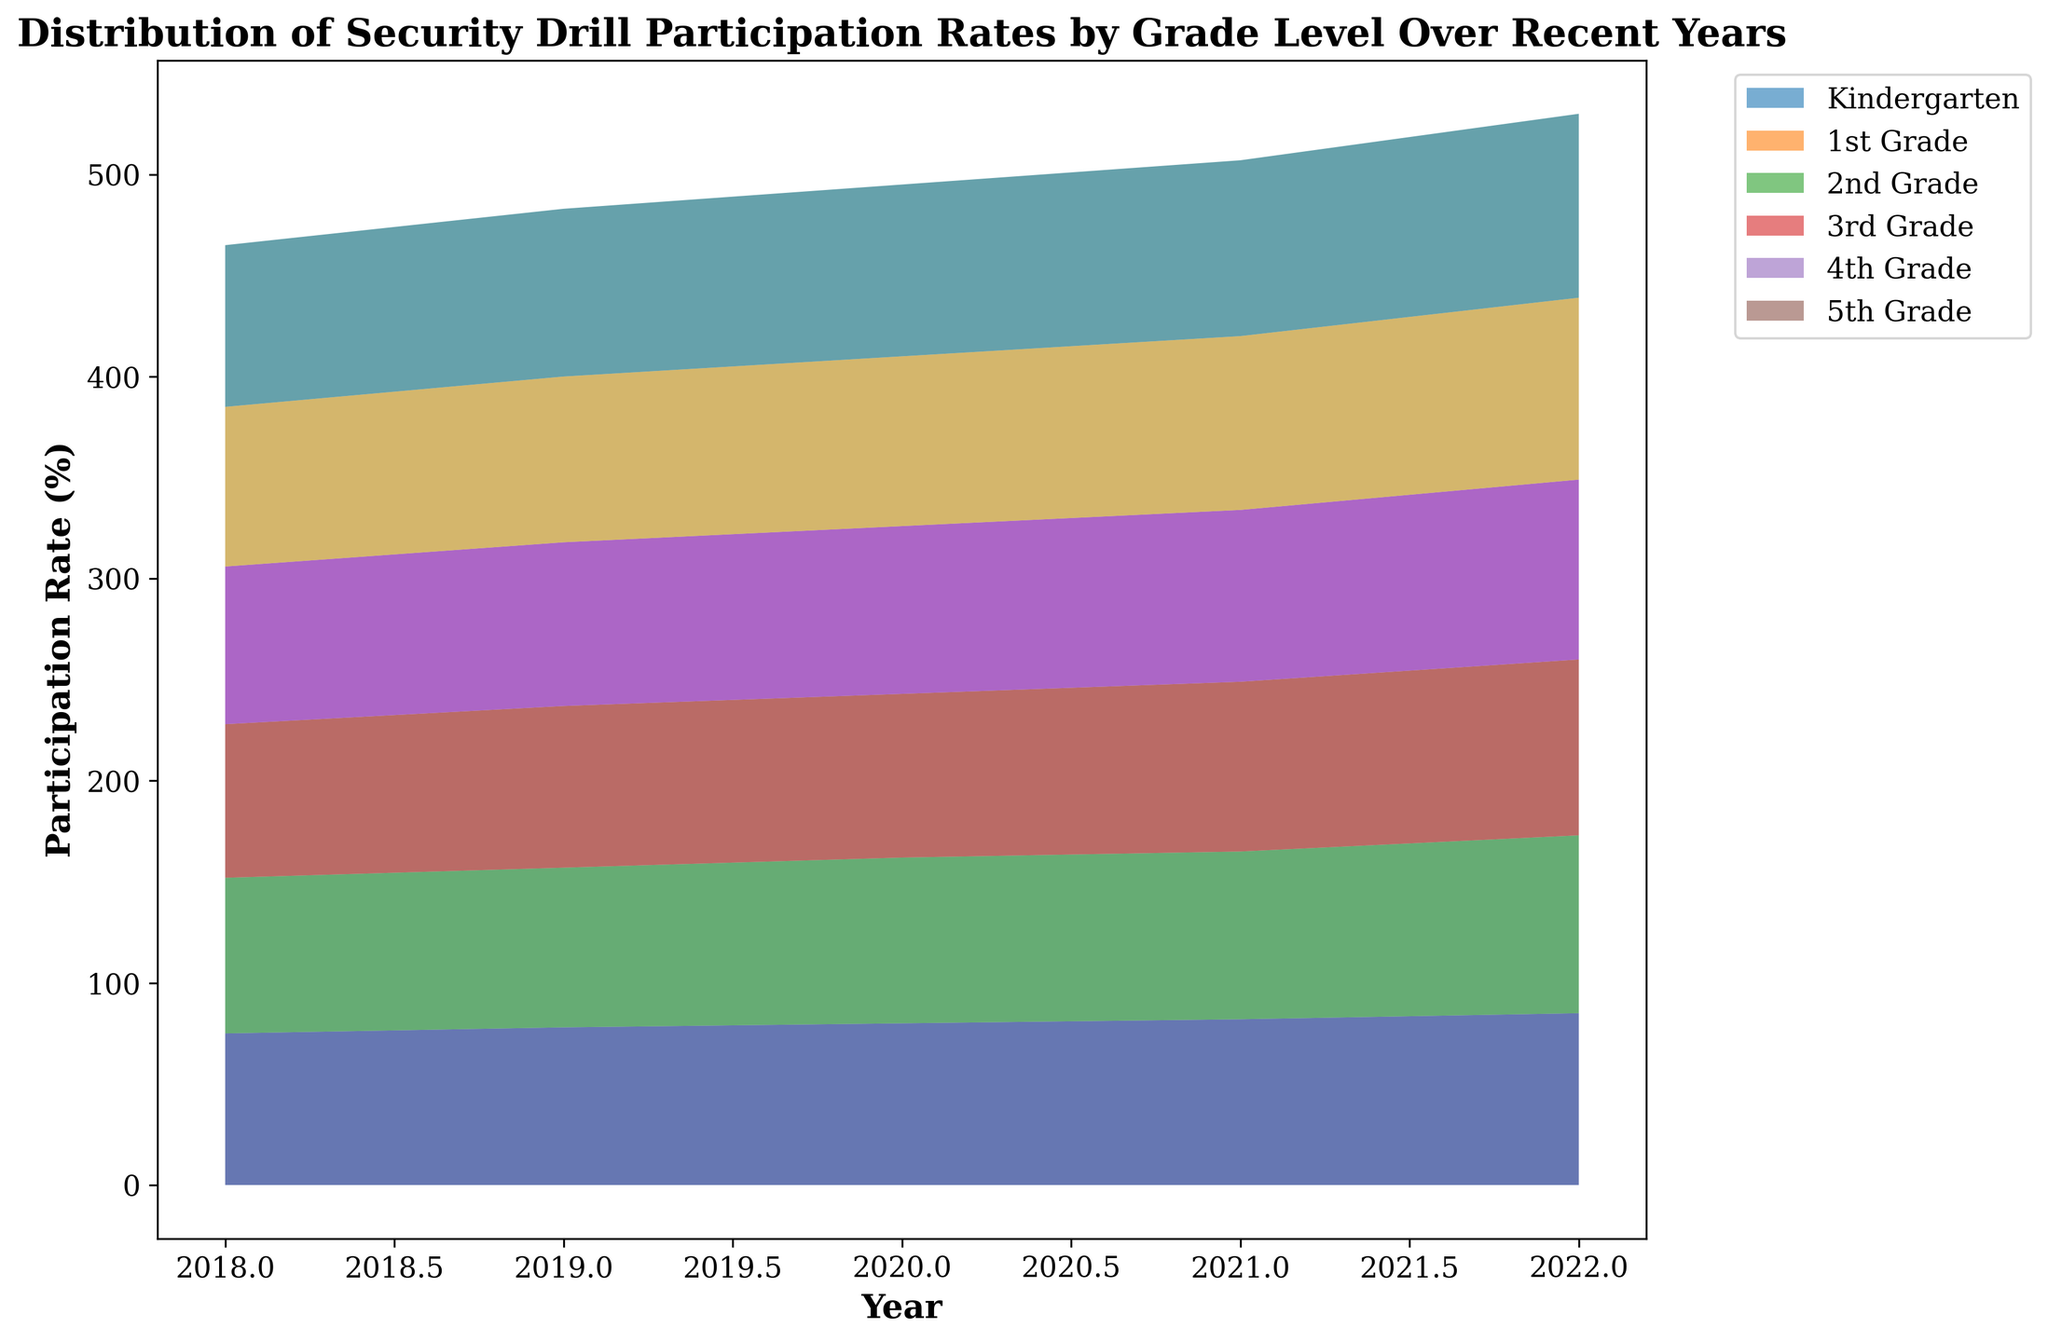Which grade level showed the highest increase in participation rate from 2018 to 2022? To find the grade level with the highest increase, calculate the difference in participation rates between 2018 and 2022 for each grade level. Kindergarten increased by 10%, 1st Grade by 11%, 2nd Grade by 11%, 3rd Grade by 11%, 4th Grade by 11%, and 5th Grade by 11%. All grades show the same increase of 11%.
Answer: All grades Which grade level had the highest participation rate in 2022? Look at the heights of the sections for each grade in 2022. The tallest section corresponds to the highest participation rate. The 5th Grade has the highest section in 2022.
Answer: 5th Grade How did the overall participation rate trend from 2018 to 2022? Observe the overall height of the area chart from 2018 to 2022. The height increases consistently each year, showing a positive trend.
Answer: Increasing Which grade had the lowest participation rate in 2018 and what was the rate? Look at the sections of the area chart representing each grade for 2018. The lowest section is for Kindergarten.
Answer: Kindergarten, 75% By how much did the Kindergarten participation rate increase from 2018 to 2022? Subtract the participation rate of Kindergarten in 2018 (75%) from the participation rate in 2022 (85%). The increase is 85% - 75%.
Answer: 10% How did the participation rate for 1st Grade in 2020 compare to that in 2018? Compare the heights of the 1st Grade sections for 2018 and 2020. In 2018, it was 77%, and in 2020, it was 82%.
Answer: Increased by 5% Which two consecutive years showed the largest overall increase in participation rates? Examine the overall height increase between consecutive years. The largest increase is between 2021 and 2022.
Answer: 2021 and 2022 